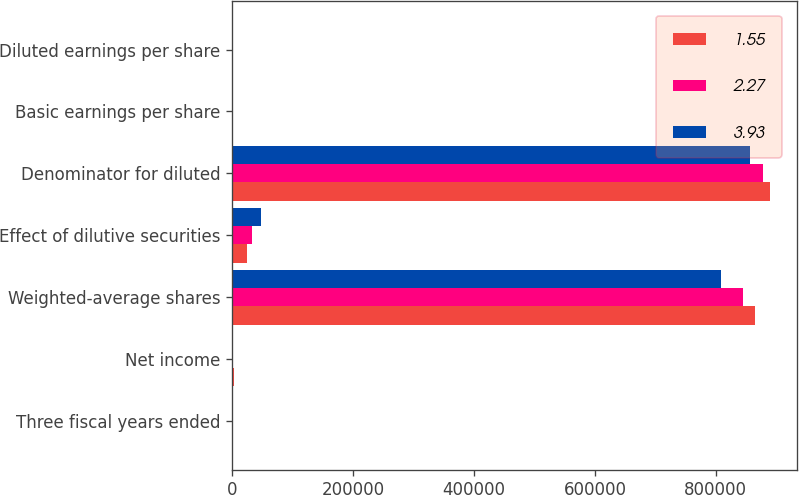Convert chart to OTSL. <chart><loc_0><loc_0><loc_500><loc_500><stacked_bar_chart><ecel><fcel>Three fiscal years ended<fcel>Net income<fcel>Weighted-average shares<fcel>Effect of dilutive securities<fcel>Denominator for diluted<fcel>Basic earnings per share<fcel>Diluted earnings per share<nl><fcel>1.55<fcel>2007<fcel>3496<fcel>864595<fcel>24697<fcel>889292<fcel>4.04<fcel>3.93<nl><fcel>2.27<fcel>2006<fcel>1989<fcel>844058<fcel>33468<fcel>877526<fcel>2.36<fcel>2.27<nl><fcel>3.93<fcel>2005<fcel>1328<fcel>808439<fcel>48439<fcel>856878<fcel>1.64<fcel>1.55<nl></chart> 